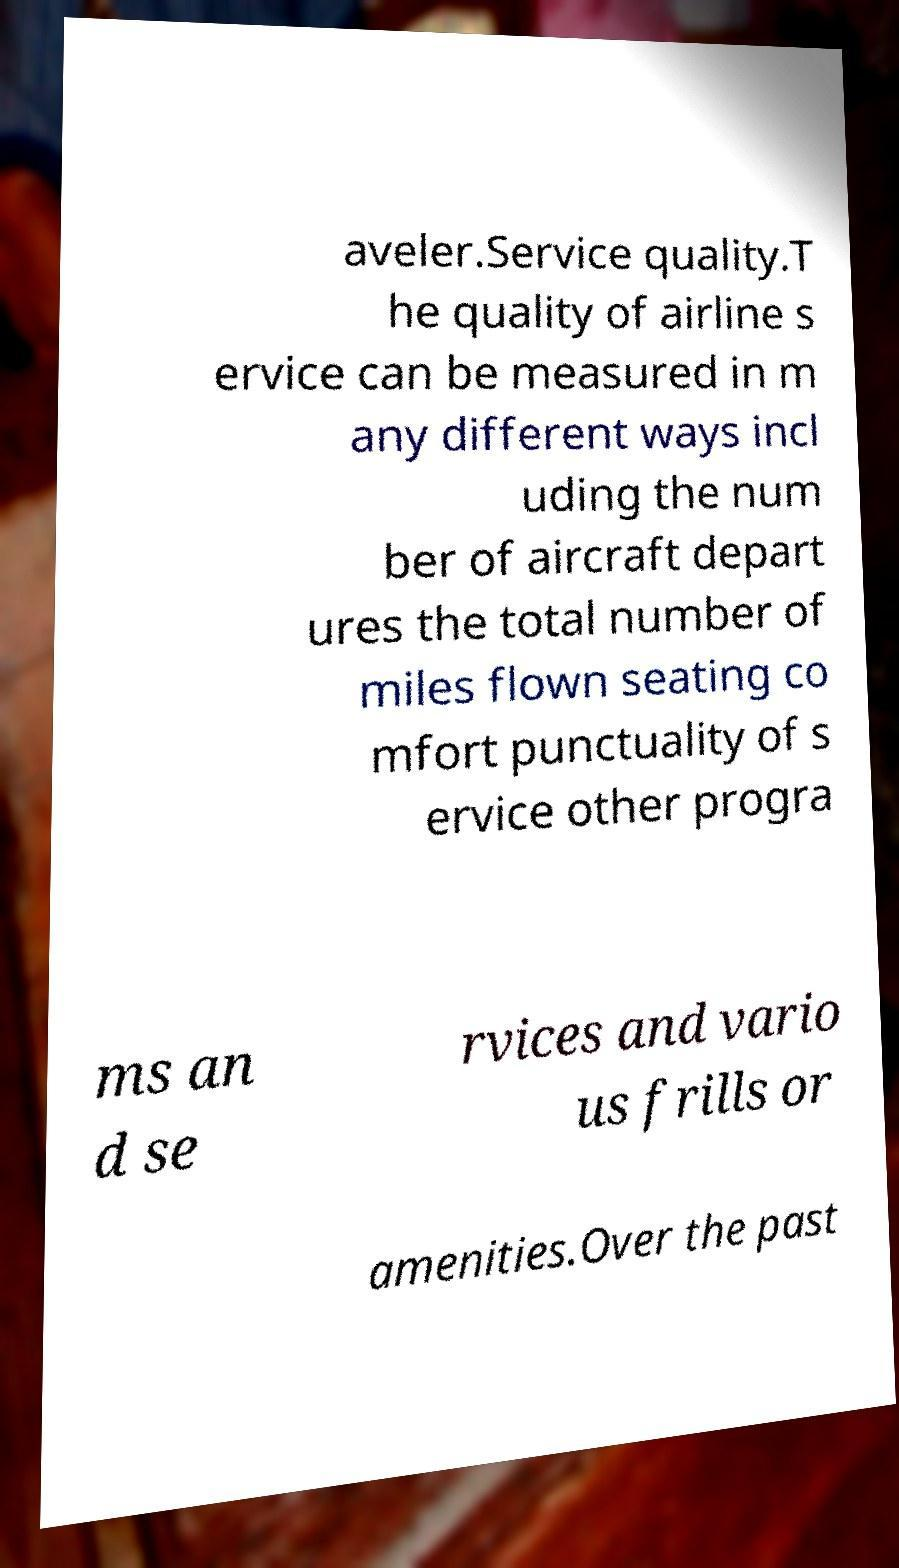Can you accurately transcribe the text from the provided image for me? aveler.Service quality.T he quality of airline s ervice can be measured in m any different ways incl uding the num ber of aircraft depart ures the total number of miles flown seating co mfort punctuality of s ervice other progra ms an d se rvices and vario us frills or amenities.Over the past 